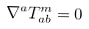<formula> <loc_0><loc_0><loc_500><loc_500>\nabla ^ { a } T ^ { m } _ { a b } = 0</formula> 